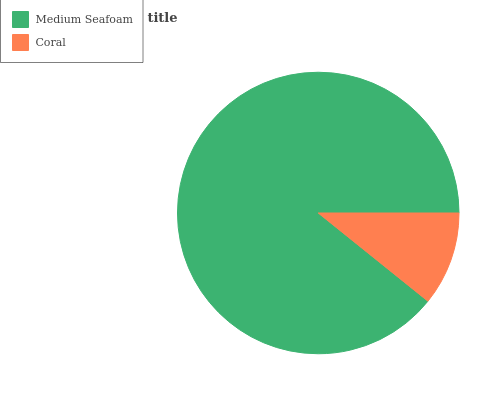Is Coral the minimum?
Answer yes or no. Yes. Is Medium Seafoam the maximum?
Answer yes or no. Yes. Is Coral the maximum?
Answer yes or no. No. Is Medium Seafoam greater than Coral?
Answer yes or no. Yes. Is Coral less than Medium Seafoam?
Answer yes or no. Yes. Is Coral greater than Medium Seafoam?
Answer yes or no. No. Is Medium Seafoam less than Coral?
Answer yes or no. No. Is Medium Seafoam the high median?
Answer yes or no. Yes. Is Coral the low median?
Answer yes or no. Yes. Is Coral the high median?
Answer yes or no. No. Is Medium Seafoam the low median?
Answer yes or no. No. 